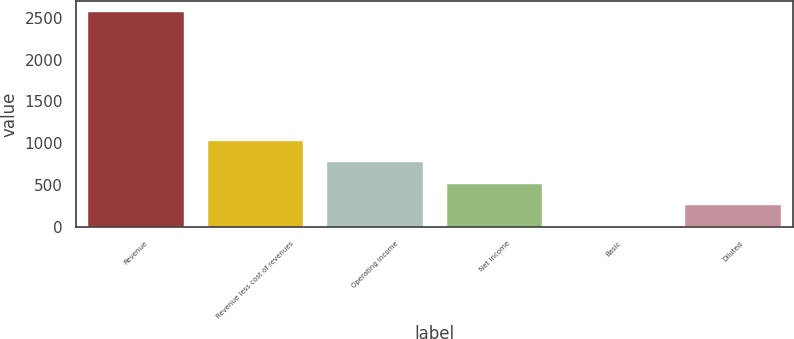<chart> <loc_0><loc_0><loc_500><loc_500><bar_chart><fcel>Revenue<fcel>Revenue less cost of revenues<fcel>Operating income<fcel>Net income<fcel>Basic<fcel>Diluted<nl><fcel>2572<fcel>1030.02<fcel>773.03<fcel>516.04<fcel>2.06<fcel>259.05<nl></chart> 